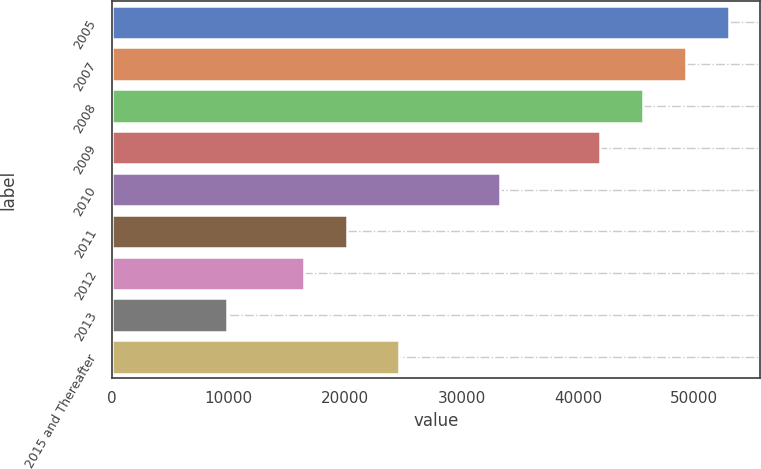<chart> <loc_0><loc_0><loc_500><loc_500><bar_chart><fcel>2005<fcel>2007<fcel>2008<fcel>2009<fcel>2010<fcel>2011<fcel>2012<fcel>2013<fcel>2015 and Thereafter<nl><fcel>52975.4<fcel>49293.6<fcel>45611.8<fcel>41930<fcel>33337<fcel>20138.8<fcel>16457<fcel>9827<fcel>24594<nl></chart> 